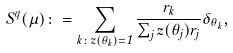Convert formula to latex. <formula><loc_0><loc_0><loc_500><loc_500>S ^ { q } ( \mu ) \colon = \sum _ { k \colon z ( \theta _ { k } ) = 1 } \frac { r _ { k } } { \sum _ { j } z ( \theta _ { j } ) r _ { j } } \delta _ { \theta _ { k } } ,</formula> 